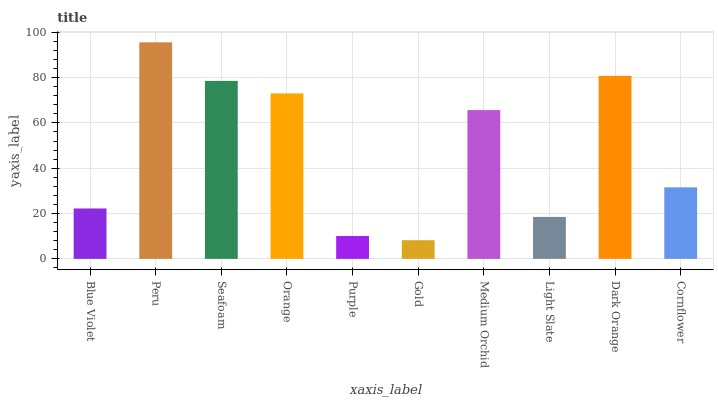Is Seafoam the minimum?
Answer yes or no. No. Is Seafoam the maximum?
Answer yes or no. No. Is Peru greater than Seafoam?
Answer yes or no. Yes. Is Seafoam less than Peru?
Answer yes or no. Yes. Is Seafoam greater than Peru?
Answer yes or no. No. Is Peru less than Seafoam?
Answer yes or no. No. Is Medium Orchid the high median?
Answer yes or no. Yes. Is Cornflower the low median?
Answer yes or no. Yes. Is Dark Orange the high median?
Answer yes or no. No. Is Orange the low median?
Answer yes or no. No. 